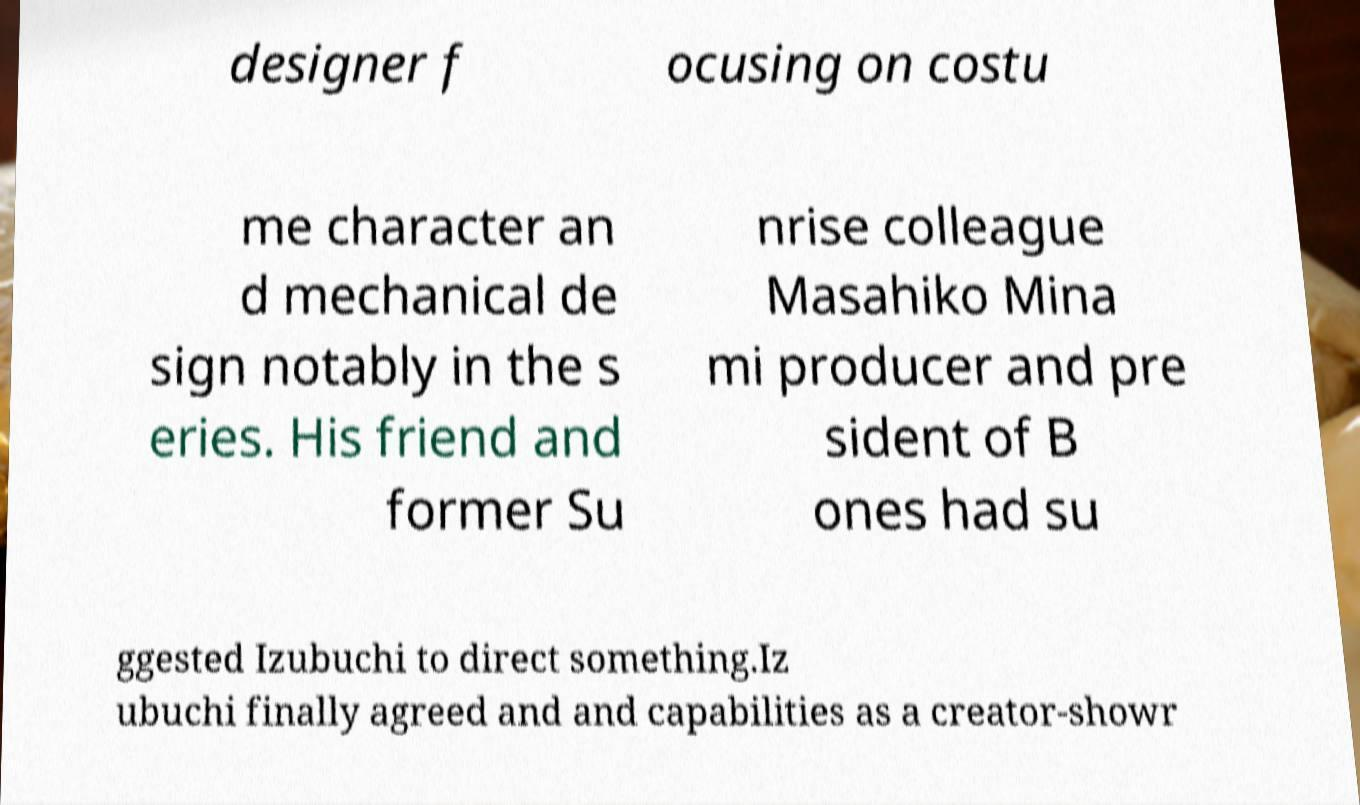For documentation purposes, I need the text within this image transcribed. Could you provide that? designer f ocusing on costu me character an d mechanical de sign notably in the s eries. His friend and former Su nrise colleague Masahiko Mina mi producer and pre sident of B ones had su ggested Izubuchi to direct something.Iz ubuchi finally agreed and and capabilities as a creator-showr 